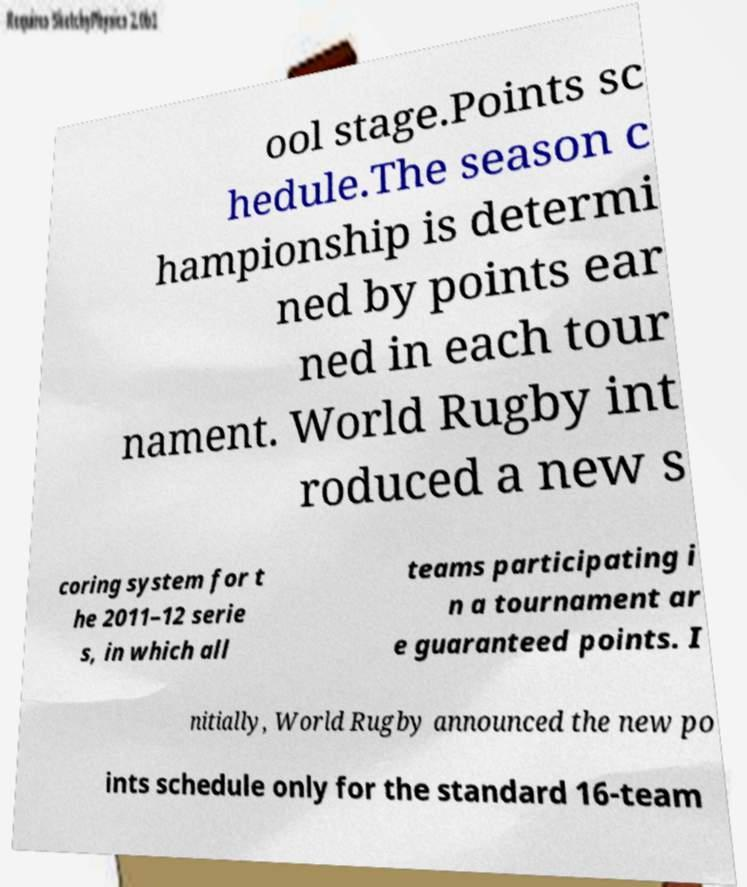What messages or text are displayed in this image? I need them in a readable, typed format. ool stage.Points sc hedule.The season c hampionship is determi ned by points ear ned in each tour nament. World Rugby int roduced a new s coring system for t he 2011–12 serie s, in which all teams participating i n a tournament ar e guaranteed points. I nitially, World Rugby announced the new po ints schedule only for the standard 16-team 